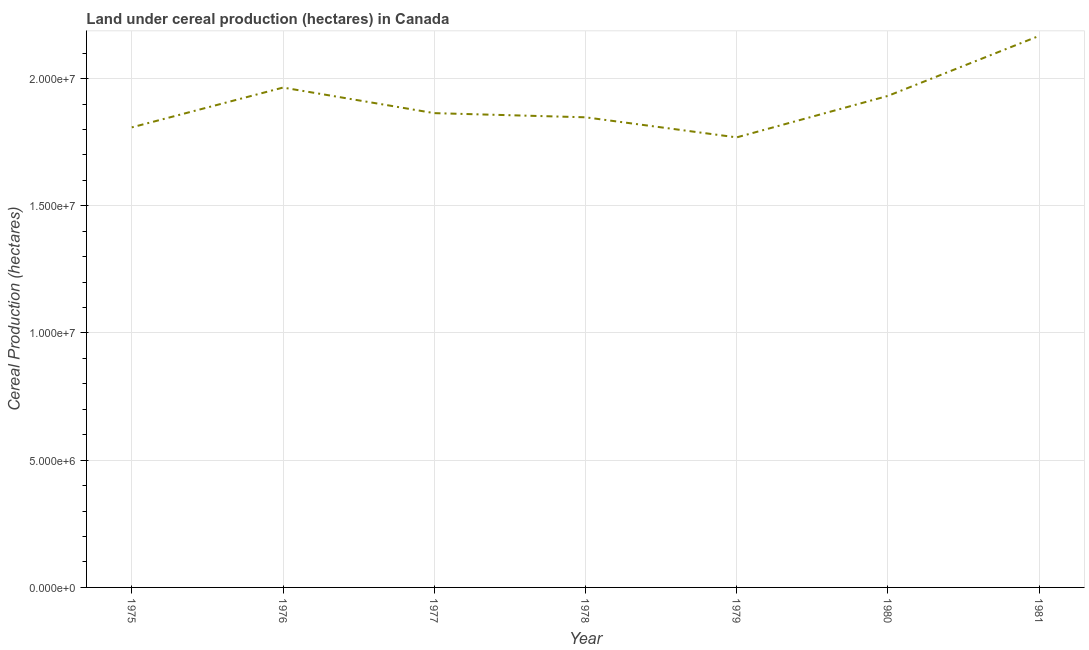What is the land under cereal production in 1981?
Give a very brief answer. 2.17e+07. Across all years, what is the maximum land under cereal production?
Keep it short and to the point. 2.17e+07. Across all years, what is the minimum land under cereal production?
Keep it short and to the point. 1.77e+07. In which year was the land under cereal production maximum?
Offer a terse response. 1981. In which year was the land under cereal production minimum?
Make the answer very short. 1979. What is the sum of the land under cereal production?
Your response must be concise. 1.34e+08. What is the difference between the land under cereal production in 1979 and 1981?
Give a very brief answer. -3.99e+06. What is the average land under cereal production per year?
Offer a very short reply. 1.91e+07. What is the median land under cereal production?
Provide a short and direct response. 1.86e+07. What is the ratio of the land under cereal production in 1979 to that in 1980?
Offer a very short reply. 0.92. Is the land under cereal production in 1978 less than that in 1981?
Provide a short and direct response. Yes. What is the difference between the highest and the second highest land under cereal production?
Your response must be concise. 2.03e+06. Is the sum of the land under cereal production in 1977 and 1978 greater than the maximum land under cereal production across all years?
Offer a very short reply. Yes. What is the difference between the highest and the lowest land under cereal production?
Offer a very short reply. 3.99e+06. In how many years, is the land under cereal production greater than the average land under cereal production taken over all years?
Your response must be concise. 3. What is the difference between two consecutive major ticks on the Y-axis?
Provide a short and direct response. 5.00e+06. Does the graph contain any zero values?
Ensure brevity in your answer.  No. Does the graph contain grids?
Offer a terse response. Yes. What is the title of the graph?
Give a very brief answer. Land under cereal production (hectares) in Canada. What is the label or title of the Y-axis?
Your answer should be very brief. Cereal Production (hectares). What is the Cereal Production (hectares) of 1975?
Your response must be concise. 1.81e+07. What is the Cereal Production (hectares) in 1976?
Your answer should be very brief. 1.96e+07. What is the Cereal Production (hectares) of 1977?
Your response must be concise. 1.86e+07. What is the Cereal Production (hectares) in 1978?
Provide a succinct answer. 1.85e+07. What is the Cereal Production (hectares) in 1979?
Make the answer very short. 1.77e+07. What is the Cereal Production (hectares) in 1980?
Your answer should be compact. 1.93e+07. What is the Cereal Production (hectares) in 1981?
Ensure brevity in your answer.  2.17e+07. What is the difference between the Cereal Production (hectares) in 1975 and 1976?
Provide a short and direct response. -1.56e+06. What is the difference between the Cereal Production (hectares) in 1975 and 1977?
Offer a very short reply. -5.59e+05. What is the difference between the Cereal Production (hectares) in 1975 and 1978?
Keep it short and to the point. -3.96e+05. What is the difference between the Cereal Production (hectares) in 1975 and 1979?
Your answer should be compact. 3.93e+05. What is the difference between the Cereal Production (hectares) in 1975 and 1980?
Keep it short and to the point. -1.24e+06. What is the difference between the Cereal Production (hectares) in 1975 and 1981?
Offer a very short reply. -3.60e+06. What is the difference between the Cereal Production (hectares) in 1976 and 1977?
Your answer should be very brief. 1.01e+06. What is the difference between the Cereal Production (hectares) in 1976 and 1978?
Provide a succinct answer. 1.17e+06. What is the difference between the Cereal Production (hectares) in 1976 and 1979?
Ensure brevity in your answer.  1.96e+06. What is the difference between the Cereal Production (hectares) in 1976 and 1980?
Your answer should be compact. 3.27e+05. What is the difference between the Cereal Production (hectares) in 1976 and 1981?
Give a very brief answer. -2.03e+06. What is the difference between the Cereal Production (hectares) in 1977 and 1978?
Offer a terse response. 1.64e+05. What is the difference between the Cereal Production (hectares) in 1977 and 1979?
Provide a short and direct response. 9.53e+05. What is the difference between the Cereal Production (hectares) in 1977 and 1980?
Your answer should be very brief. -6.78e+05. What is the difference between the Cereal Production (hectares) in 1977 and 1981?
Make the answer very short. -3.04e+06. What is the difference between the Cereal Production (hectares) in 1978 and 1979?
Ensure brevity in your answer.  7.89e+05. What is the difference between the Cereal Production (hectares) in 1978 and 1980?
Your answer should be compact. -8.41e+05. What is the difference between the Cereal Production (hectares) in 1978 and 1981?
Make the answer very short. -3.20e+06. What is the difference between the Cereal Production (hectares) in 1979 and 1980?
Offer a very short reply. -1.63e+06. What is the difference between the Cereal Production (hectares) in 1979 and 1981?
Ensure brevity in your answer.  -3.99e+06. What is the difference between the Cereal Production (hectares) in 1980 and 1981?
Keep it short and to the point. -2.36e+06. What is the ratio of the Cereal Production (hectares) in 1975 to that in 1977?
Make the answer very short. 0.97. What is the ratio of the Cereal Production (hectares) in 1975 to that in 1978?
Offer a terse response. 0.98. What is the ratio of the Cereal Production (hectares) in 1975 to that in 1980?
Offer a terse response. 0.94. What is the ratio of the Cereal Production (hectares) in 1975 to that in 1981?
Your response must be concise. 0.83. What is the ratio of the Cereal Production (hectares) in 1976 to that in 1977?
Give a very brief answer. 1.05. What is the ratio of the Cereal Production (hectares) in 1976 to that in 1978?
Your response must be concise. 1.06. What is the ratio of the Cereal Production (hectares) in 1976 to that in 1979?
Your answer should be very brief. 1.11. What is the ratio of the Cereal Production (hectares) in 1976 to that in 1980?
Keep it short and to the point. 1.02. What is the ratio of the Cereal Production (hectares) in 1976 to that in 1981?
Make the answer very short. 0.91. What is the ratio of the Cereal Production (hectares) in 1977 to that in 1979?
Your response must be concise. 1.05. What is the ratio of the Cereal Production (hectares) in 1977 to that in 1981?
Provide a succinct answer. 0.86. What is the ratio of the Cereal Production (hectares) in 1978 to that in 1979?
Your answer should be very brief. 1.04. What is the ratio of the Cereal Production (hectares) in 1978 to that in 1980?
Ensure brevity in your answer.  0.96. What is the ratio of the Cereal Production (hectares) in 1978 to that in 1981?
Provide a succinct answer. 0.85. What is the ratio of the Cereal Production (hectares) in 1979 to that in 1980?
Provide a short and direct response. 0.92. What is the ratio of the Cereal Production (hectares) in 1979 to that in 1981?
Provide a succinct answer. 0.82. What is the ratio of the Cereal Production (hectares) in 1980 to that in 1981?
Your answer should be compact. 0.89. 